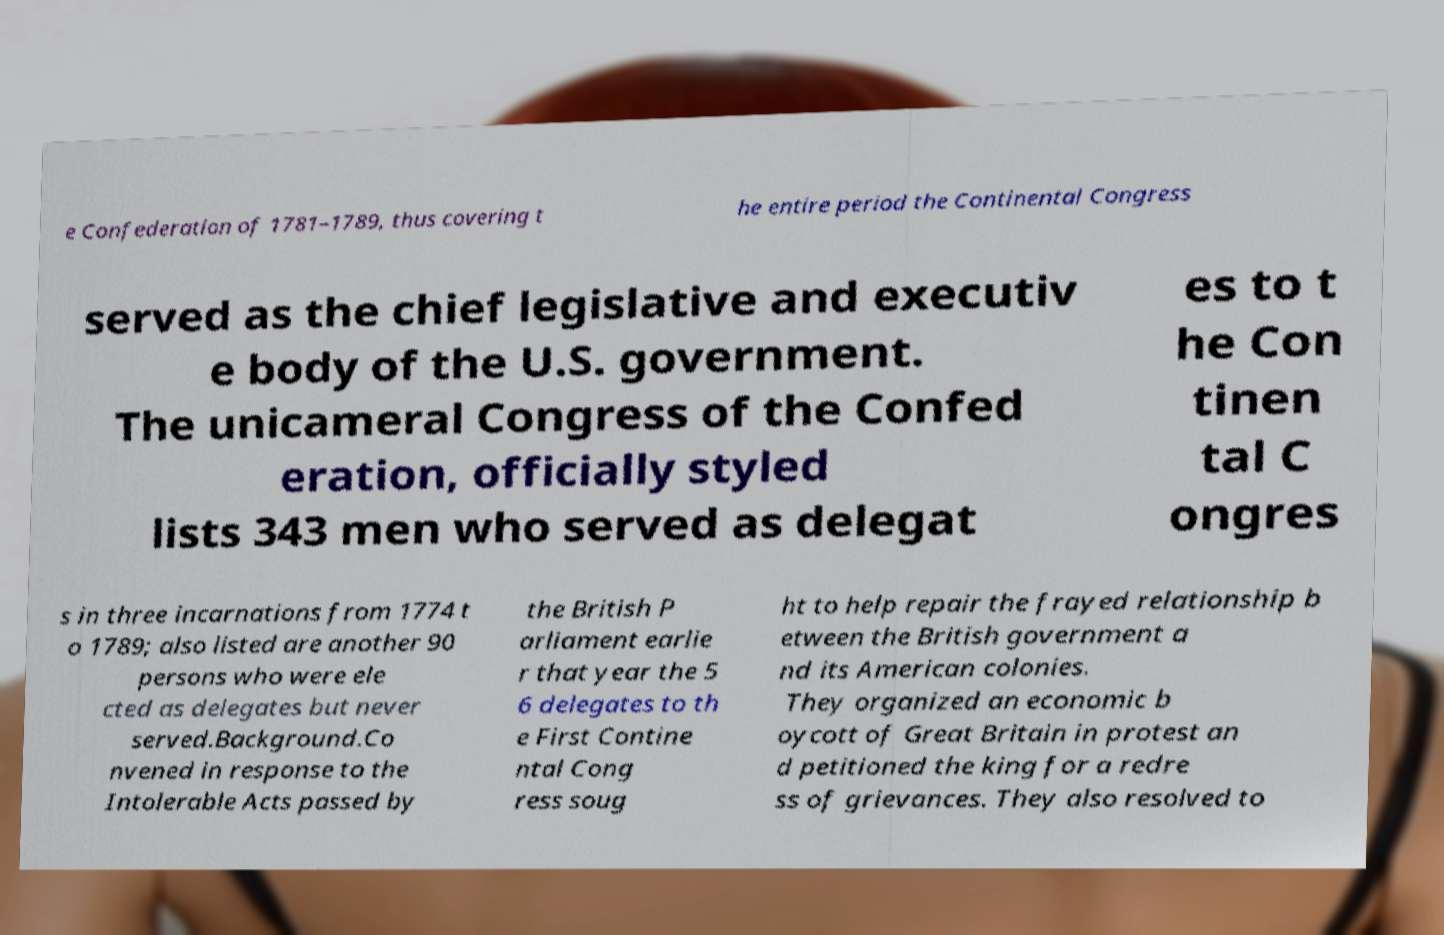Can you read and provide the text displayed in the image?This photo seems to have some interesting text. Can you extract and type it out for me? e Confederation of 1781–1789, thus covering t he entire period the Continental Congress served as the chief legislative and executiv e body of the U.S. government. The unicameral Congress of the Confed eration, officially styled lists 343 men who served as delegat es to t he Con tinen tal C ongres s in three incarnations from 1774 t o 1789; also listed are another 90 persons who were ele cted as delegates but never served.Background.Co nvened in response to the Intolerable Acts passed by the British P arliament earlie r that year the 5 6 delegates to th e First Contine ntal Cong ress soug ht to help repair the frayed relationship b etween the British government a nd its American colonies. They organized an economic b oycott of Great Britain in protest an d petitioned the king for a redre ss of grievances. They also resolved to 